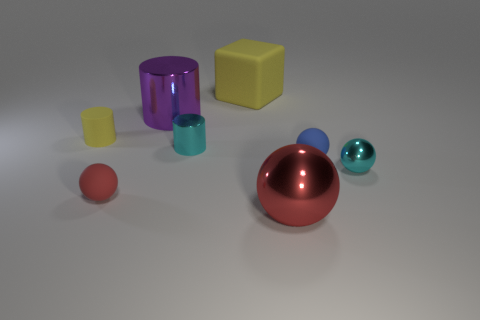Subtract all big metallic balls. How many balls are left? 3 Subtract all yellow cylinders. How many cylinders are left? 2 Add 2 large objects. How many objects exist? 10 Subtract 3 cylinders. How many cylinders are left? 0 Subtract all blocks. How many objects are left? 7 Subtract all blue cylinders. Subtract all green balls. How many cylinders are left? 3 Subtract all yellow cylinders. How many red spheres are left? 2 Subtract all red rubber balls. Subtract all small metallic balls. How many objects are left? 6 Add 3 small cylinders. How many small cylinders are left? 5 Add 1 cylinders. How many cylinders exist? 4 